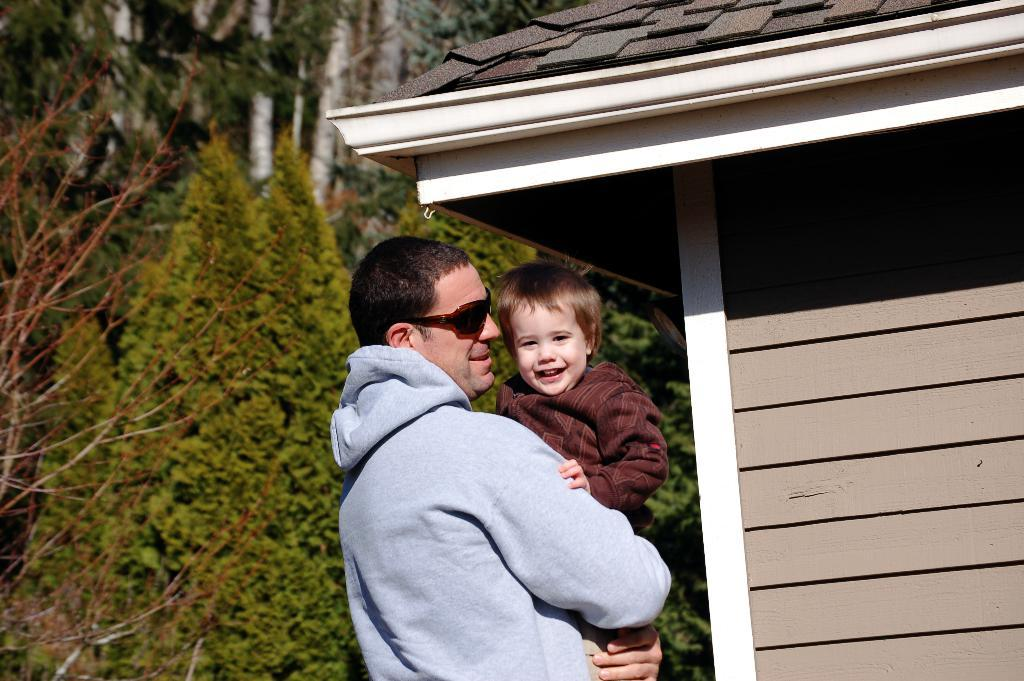What is the main subject of the image? The main subject of the image is a man. What is the man wearing? The man is wearing a jacket and goggles. What is the man doing in the image? The man is carrying a child and smiling. What can be seen in the background of the image? There are trees in the background of the image. What structure is present in the image? There is a shed in the image. What type of garden can be seen in the image? There is no garden present in the image. What is the man's reaction to the ice in the image? There is no ice present in the image, so it is not possible to determine the man's reaction to it. 